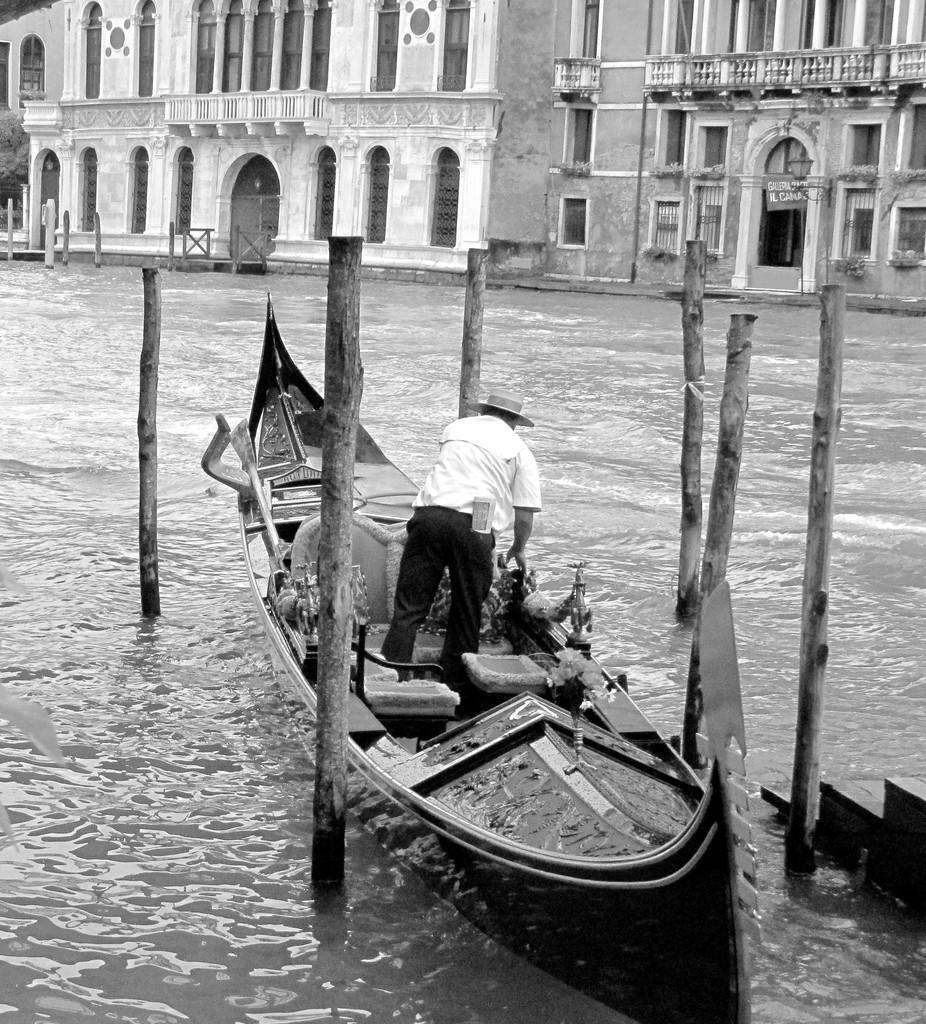Please provide a concise description of this image. In this image we can see a ship in the water. Here we can see a man and wooden chairs in the ship. In the background, we can see the buildings. 